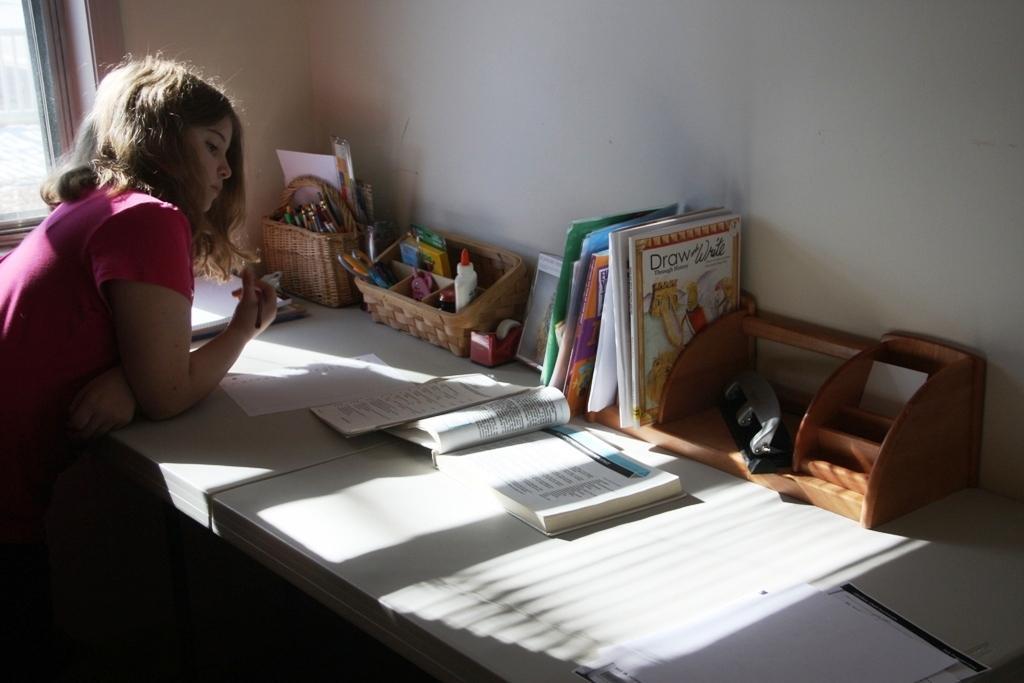Describe this image in one or two sentences. In this image I see a girl and there is a table in front and there are pens, books and 2 baskets in which there are few things and I can also see papers and there is a wall over here. 